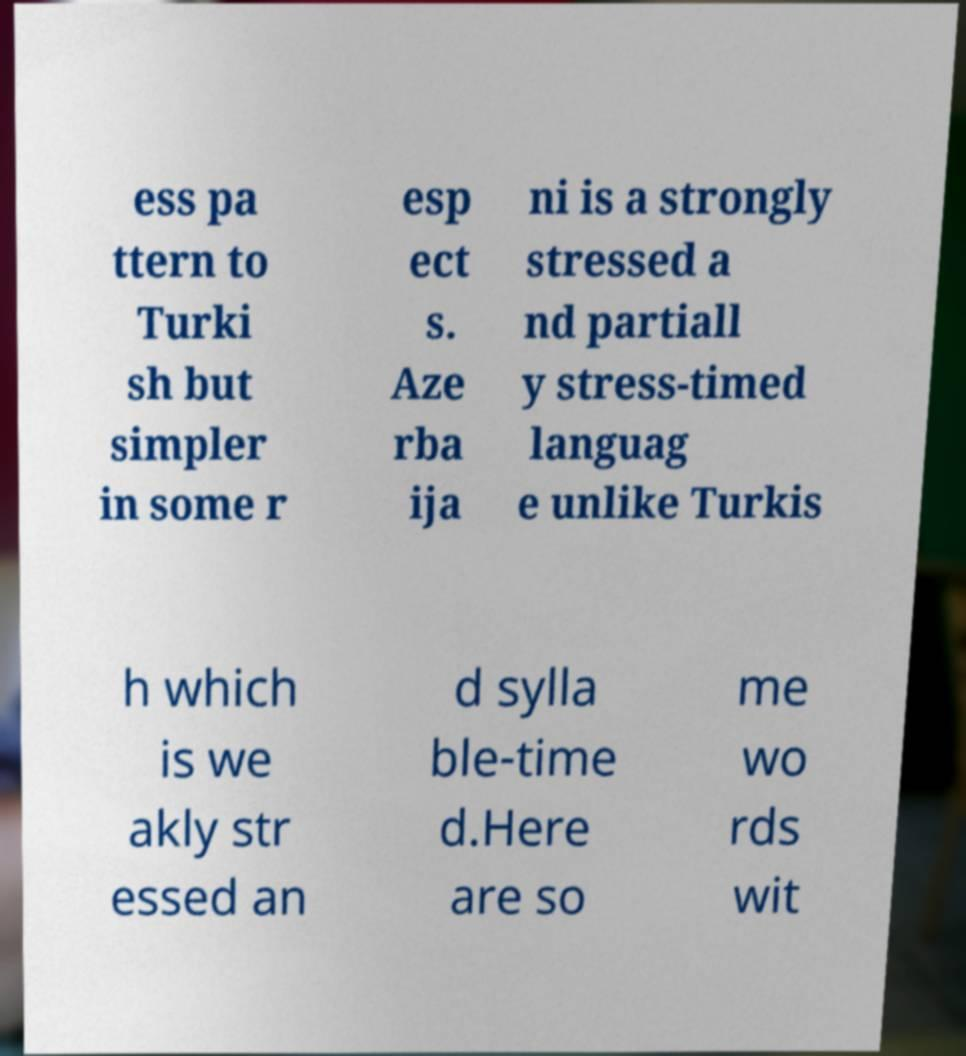Can you accurately transcribe the text from the provided image for me? ess pa ttern to Turki sh but simpler in some r esp ect s. Aze rba ija ni is a strongly stressed a nd partiall y stress-timed languag e unlike Turkis h which is we akly str essed an d sylla ble-time d.Here are so me wo rds wit 